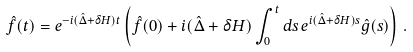<formula> <loc_0><loc_0><loc_500><loc_500>\hat { f } ( t ) = e ^ { - i ( \hat { \Delta } + \delta H ) t } \left ( \hat { f } ( 0 ) + i ( \hat { \Delta } + \delta H ) \int _ { 0 } ^ { t } d s \, e ^ { i ( \hat { \Delta } + \delta H ) s } \hat { g } ( s ) \right ) \, .</formula> 